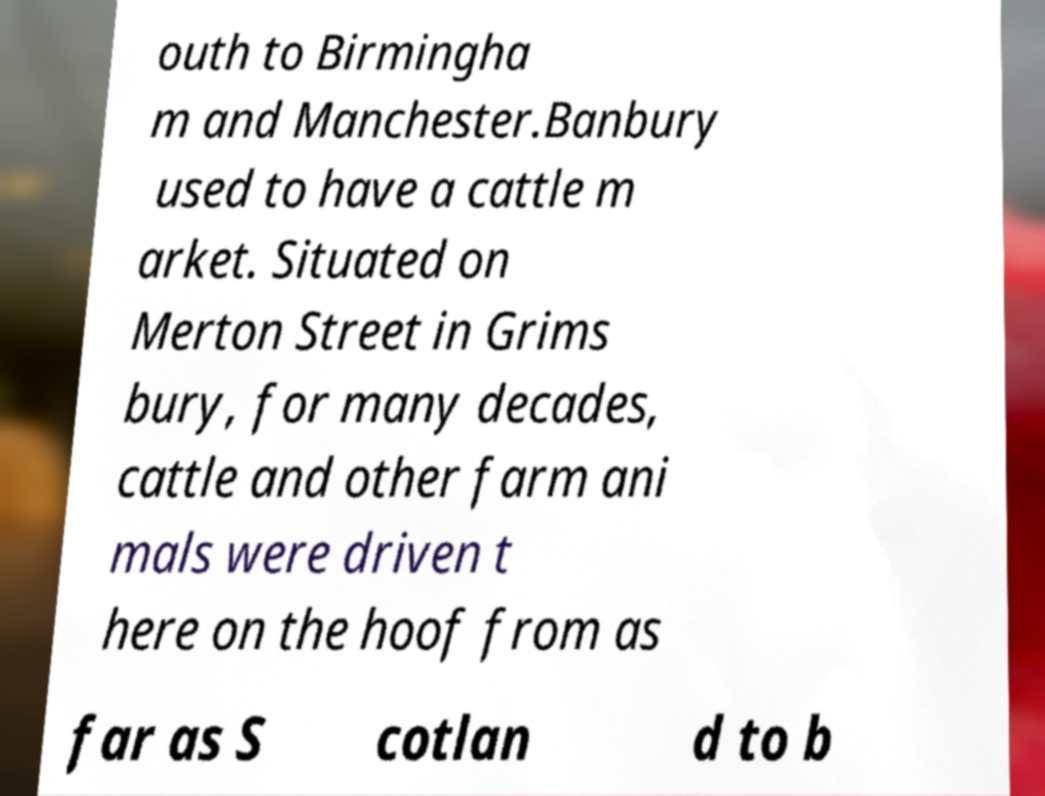Could you assist in decoding the text presented in this image and type it out clearly? outh to Birmingha m and Manchester.Banbury used to have a cattle m arket. Situated on Merton Street in Grims bury, for many decades, cattle and other farm ani mals were driven t here on the hoof from as far as S cotlan d to b 